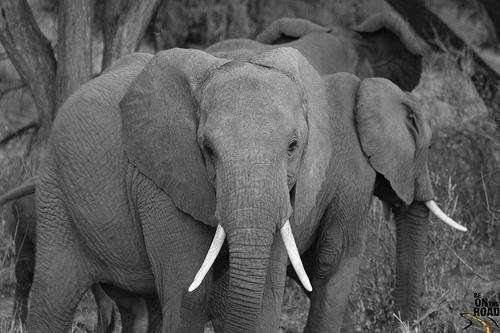How many elephants are looking at the camera?
Give a very brief answer. 1. How many elephants are facing the camera?
Give a very brief answer. 1. 